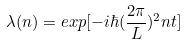<formula> <loc_0><loc_0><loc_500><loc_500>\lambda ( n ) = e x p [ - i \hbar { ( } \frac { 2 \pi } { L } ) ^ { 2 } n t ]</formula> 